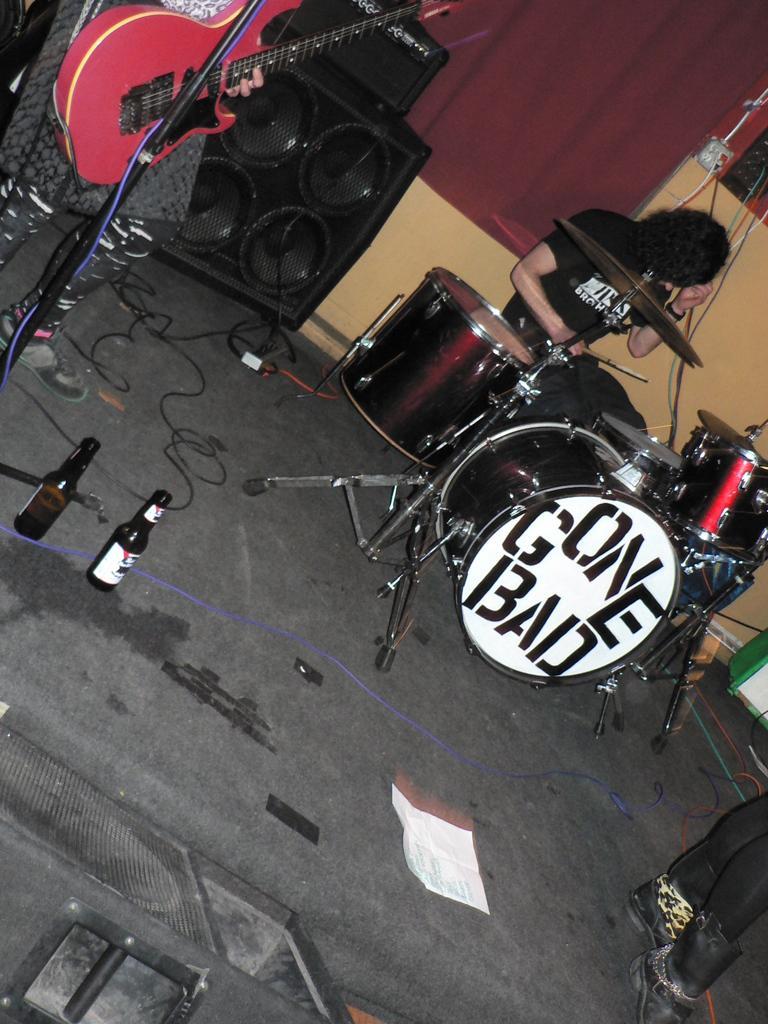Please provide a concise description of this image. In this image I can see the black colored floor, two bottles, few wires, few musical instruments, a person sitting, few speakers, the curtain, two persons standing and a red colored guitar. I can see a paper on the floor. 